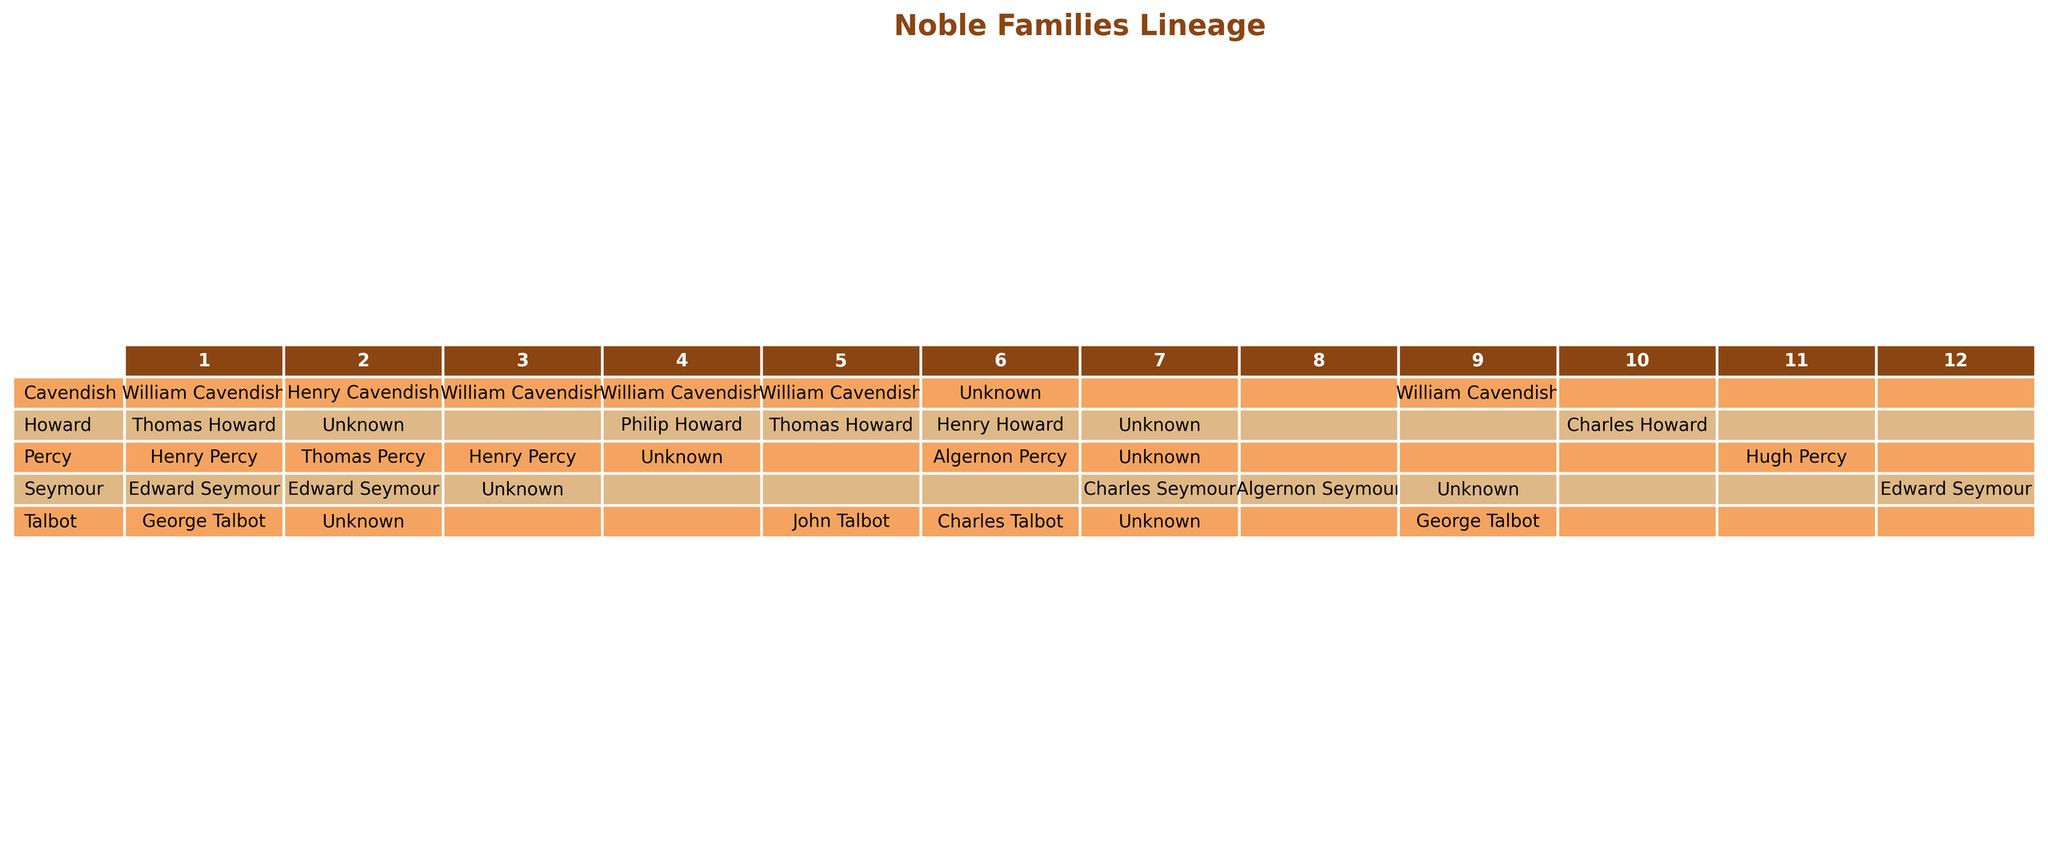What is the known heir for the Cavendish family in the year 1700? In the table, I locate the Cavendish family and find the entry for the year 1700. The known heir listed for that year is "Unknown."
Answer: Unknown How many missing generations are there for the Percy family? I count the occurrences of missing generations for the Percy family in the relevant rows of the table. There are 1, 3, and 0 for the years provided, which totals to 4 missing generations overall.
Answer: 4 Is there a known heir for the Talbot family in the year 1670? I look at the Talbot family's entry for the year 1670 in the table. The known heir for that year is listed as "Charles Talbot."
Answer: Charles Talbot What is the total number of missing generations across all families? I assess the missing generations for each family listed in the table: Cavendish has 2, Percy has 4, Howard has 3, Talbot has 3, and Seymour has 5. Adding these totals results in 2 + 4 + 3 + 3 + 5 = 17 missing generations.
Answer: 17 Did the Howard family have a known heir in the year 1510? In the table, I check the Howard family for the year 1510, and see that the known heir is "Unknown." Therefore, the answer is negative.
Answer: No Which family has the latest known heir listed, and what is that heir? Analyzing the table for the latest entry by year, I see the Seymour family has a known heir in 1830, and that heir is "Edward Seymour."
Answer: Edward Seymour How many generations are missing for the Seymour family? I observe the missing generations for the Seymour family across the provided years, which are 3, 0, 2, and 0, totaling 5 missing generations overall.
Answer: 5 Is the known heir for the fourth generation of the Percy family a confirmed name? I check the table for the Percy family’s fourth generation entry, which lists the known heir as "Unknown." Thus, it is not confirmed.
Answer: No What is the known heir for the sixth generation of the Howard family? I examine the sixth generation of the Howard family and confirm that the known heir is "Henry Howard."
Answer: Henry Howard Find the average for missing generations across all families. I count the total missing generations: 2, 4, 3, 3, 5, which sums to 17. There are five families, therefore the average is 17/5 = 3.4 generations missing.
Answer: 3.4 